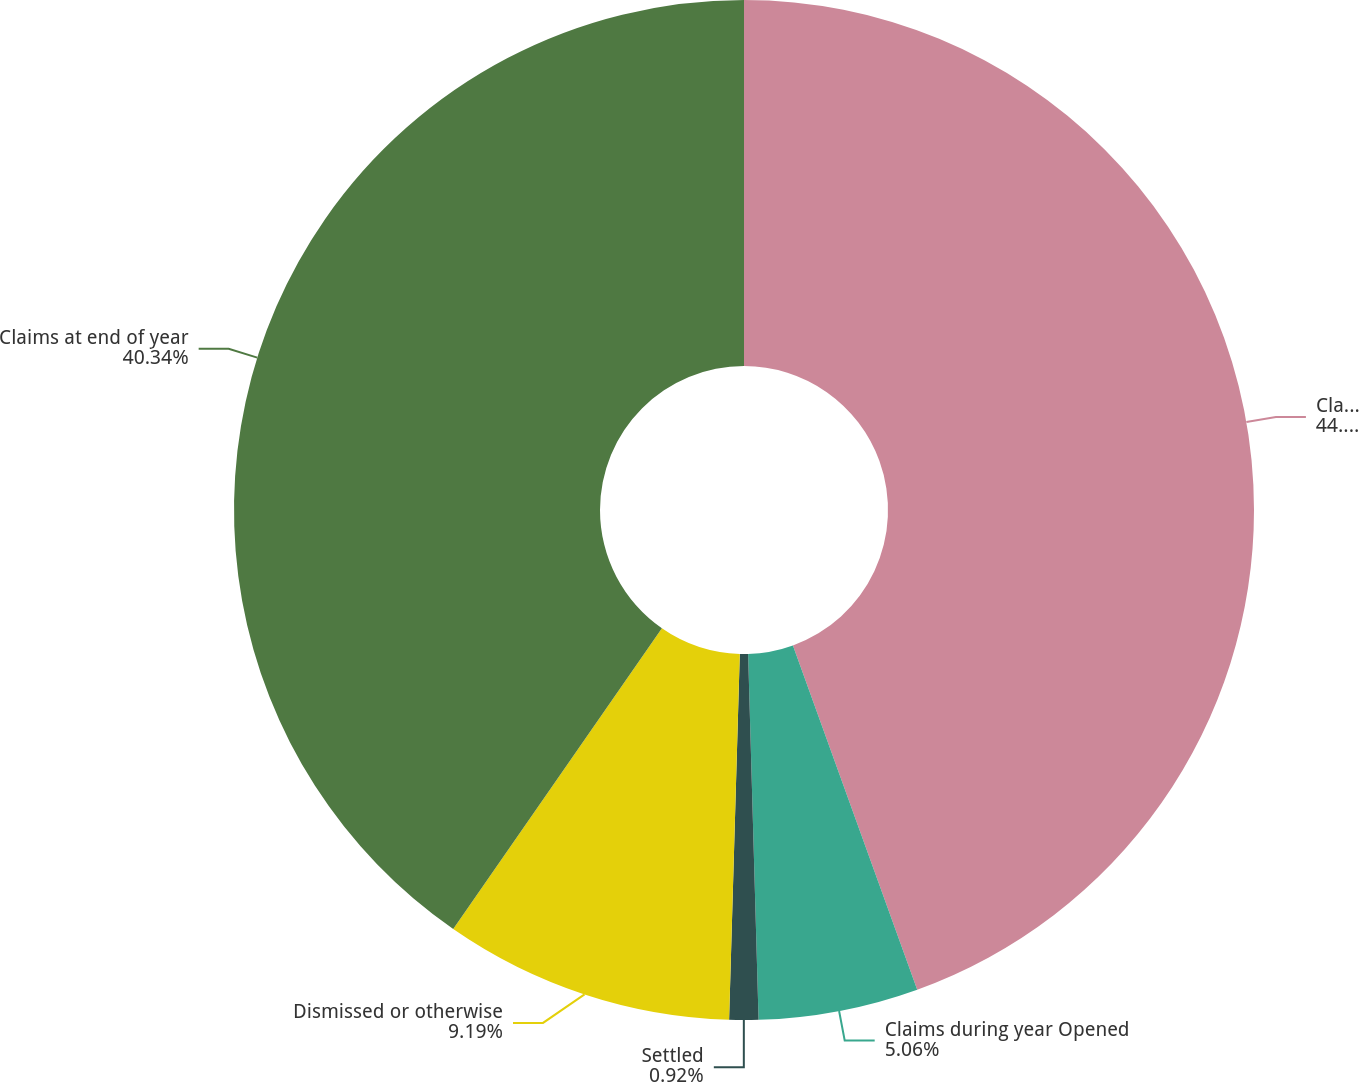Convert chart. <chart><loc_0><loc_0><loc_500><loc_500><pie_chart><fcel>Claims at beginning of year<fcel>Claims during year Opened<fcel>Settled<fcel>Dismissed or otherwise<fcel>Claims at end of year<nl><fcel>44.48%<fcel>5.06%<fcel>0.92%<fcel>9.19%<fcel>40.34%<nl></chart> 